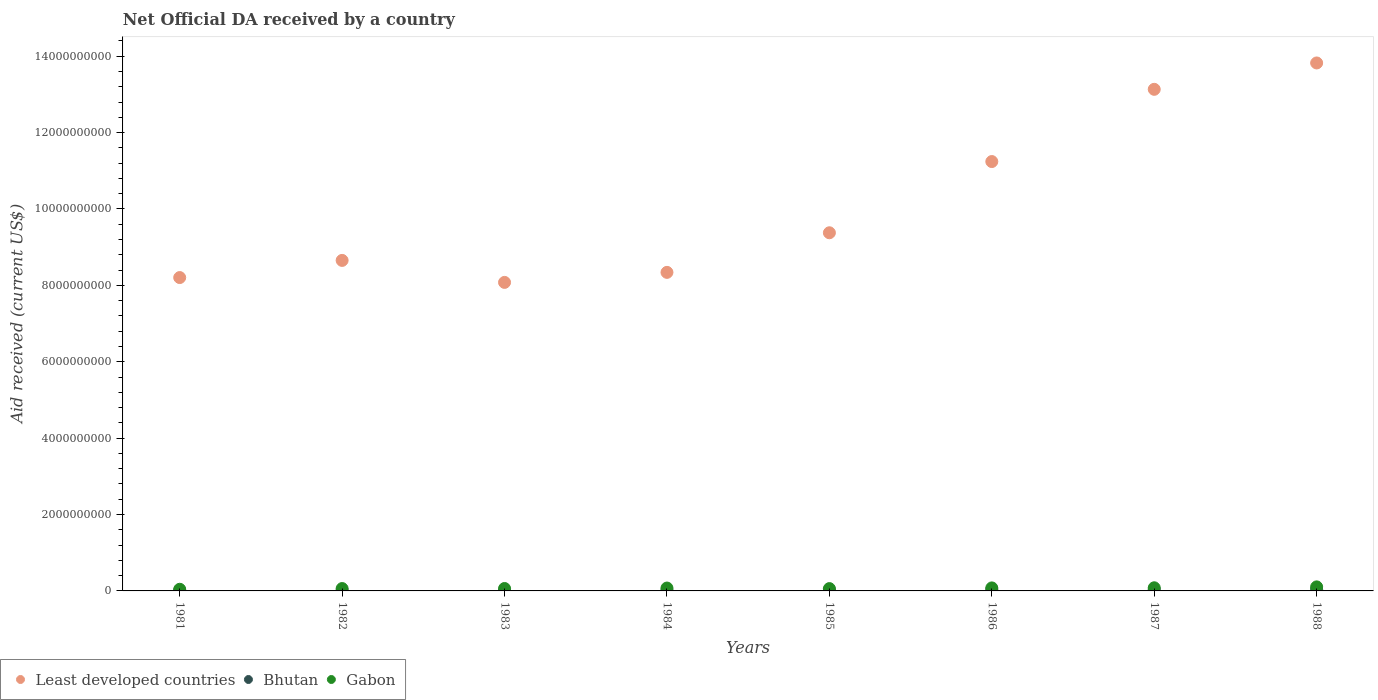Is the number of dotlines equal to the number of legend labels?
Your answer should be very brief. Yes. What is the net official development assistance aid received in Bhutan in 1981?
Your response must be concise. 9.65e+06. Across all years, what is the maximum net official development assistance aid received in Gabon?
Keep it short and to the point. 1.06e+08. Across all years, what is the minimum net official development assistance aid received in Gabon?
Your response must be concise. 4.32e+07. In which year was the net official development assistance aid received in Bhutan maximum?
Your response must be concise. 1988. In which year was the net official development assistance aid received in Gabon minimum?
Offer a very short reply. 1981. What is the total net official development assistance aid received in Least developed countries in the graph?
Provide a succinct answer. 8.08e+1. What is the difference between the net official development assistance aid received in Bhutan in 1985 and that in 1986?
Your answer should be compact. -1.55e+07. What is the difference between the net official development assistance aid received in Gabon in 1984 and the net official development assistance aid received in Bhutan in 1983?
Your response must be concise. 6.24e+07. What is the average net official development assistance aid received in Least developed countries per year?
Offer a very short reply. 1.01e+1. In the year 1981, what is the difference between the net official development assistance aid received in Gabon and net official development assistance aid received in Least developed countries?
Your answer should be very brief. -8.16e+09. In how many years, is the net official development assistance aid received in Gabon greater than 1200000000 US$?
Give a very brief answer. 0. What is the ratio of the net official development assistance aid received in Gabon in 1983 to that in 1986?
Make the answer very short. 0.81. What is the difference between the highest and the lowest net official development assistance aid received in Gabon?
Make the answer very short. 6.26e+07. Is it the case that in every year, the sum of the net official development assistance aid received in Bhutan and net official development assistance aid received in Gabon  is greater than the net official development assistance aid received in Least developed countries?
Your answer should be very brief. No. Is the net official development assistance aid received in Least developed countries strictly less than the net official development assistance aid received in Bhutan over the years?
Ensure brevity in your answer.  No. How many years are there in the graph?
Keep it short and to the point. 8. Are the values on the major ticks of Y-axis written in scientific E-notation?
Provide a short and direct response. No. Does the graph contain grids?
Offer a terse response. No. How many legend labels are there?
Offer a terse response. 3. What is the title of the graph?
Ensure brevity in your answer.  Net Official DA received by a country. Does "Afghanistan" appear as one of the legend labels in the graph?
Your answer should be compact. No. What is the label or title of the Y-axis?
Provide a short and direct response. Aid received (current US$). What is the Aid received (current US$) in Least developed countries in 1981?
Give a very brief answer. 8.20e+09. What is the Aid received (current US$) in Bhutan in 1981?
Your response must be concise. 9.65e+06. What is the Aid received (current US$) of Gabon in 1981?
Your answer should be very brief. 4.32e+07. What is the Aid received (current US$) of Least developed countries in 1982?
Your answer should be very brief. 8.65e+09. What is the Aid received (current US$) of Bhutan in 1982?
Offer a terse response. 1.12e+07. What is the Aid received (current US$) of Gabon in 1982?
Offer a very short reply. 6.18e+07. What is the Aid received (current US$) of Least developed countries in 1983?
Keep it short and to the point. 8.08e+09. What is the Aid received (current US$) in Bhutan in 1983?
Ensure brevity in your answer.  1.29e+07. What is the Aid received (current US$) of Gabon in 1983?
Provide a succinct answer. 6.35e+07. What is the Aid received (current US$) of Least developed countries in 1984?
Provide a short and direct response. 8.34e+09. What is the Aid received (current US$) in Bhutan in 1984?
Offer a very short reply. 1.72e+07. What is the Aid received (current US$) in Gabon in 1984?
Provide a succinct answer. 7.53e+07. What is the Aid received (current US$) of Least developed countries in 1985?
Your answer should be very brief. 9.38e+09. What is the Aid received (current US$) of Bhutan in 1985?
Your response must be concise. 2.34e+07. What is the Aid received (current US$) in Gabon in 1985?
Give a very brief answer. 6.08e+07. What is the Aid received (current US$) in Least developed countries in 1986?
Provide a short and direct response. 1.12e+1. What is the Aid received (current US$) of Bhutan in 1986?
Provide a short and direct response. 3.89e+07. What is the Aid received (current US$) of Gabon in 1986?
Your answer should be compact. 7.86e+07. What is the Aid received (current US$) of Least developed countries in 1987?
Your answer should be compact. 1.31e+1. What is the Aid received (current US$) in Bhutan in 1987?
Make the answer very short. 4.05e+07. What is the Aid received (current US$) of Gabon in 1987?
Make the answer very short. 8.23e+07. What is the Aid received (current US$) of Least developed countries in 1988?
Give a very brief answer. 1.38e+1. What is the Aid received (current US$) of Bhutan in 1988?
Provide a succinct answer. 4.06e+07. What is the Aid received (current US$) in Gabon in 1988?
Your answer should be compact. 1.06e+08. Across all years, what is the maximum Aid received (current US$) in Least developed countries?
Make the answer very short. 1.38e+1. Across all years, what is the maximum Aid received (current US$) in Bhutan?
Provide a short and direct response. 4.06e+07. Across all years, what is the maximum Aid received (current US$) in Gabon?
Offer a very short reply. 1.06e+08. Across all years, what is the minimum Aid received (current US$) of Least developed countries?
Provide a short and direct response. 8.08e+09. Across all years, what is the minimum Aid received (current US$) in Bhutan?
Provide a short and direct response. 9.65e+06. Across all years, what is the minimum Aid received (current US$) in Gabon?
Make the answer very short. 4.32e+07. What is the total Aid received (current US$) in Least developed countries in the graph?
Keep it short and to the point. 8.08e+1. What is the total Aid received (current US$) in Bhutan in the graph?
Provide a succinct answer. 1.94e+08. What is the total Aid received (current US$) in Gabon in the graph?
Your answer should be very brief. 5.71e+08. What is the difference between the Aid received (current US$) in Least developed countries in 1981 and that in 1982?
Your answer should be compact. -4.49e+08. What is the difference between the Aid received (current US$) of Bhutan in 1981 and that in 1982?
Provide a short and direct response. -1.60e+06. What is the difference between the Aid received (current US$) in Gabon in 1981 and that in 1982?
Offer a terse response. -1.87e+07. What is the difference between the Aid received (current US$) in Least developed countries in 1981 and that in 1983?
Keep it short and to the point. 1.27e+08. What is the difference between the Aid received (current US$) of Bhutan in 1981 and that in 1983?
Your response must be concise. -3.27e+06. What is the difference between the Aid received (current US$) of Gabon in 1981 and that in 1983?
Your answer should be compact. -2.03e+07. What is the difference between the Aid received (current US$) of Least developed countries in 1981 and that in 1984?
Provide a short and direct response. -1.36e+08. What is the difference between the Aid received (current US$) of Bhutan in 1981 and that in 1984?
Give a very brief answer. -7.59e+06. What is the difference between the Aid received (current US$) of Gabon in 1981 and that in 1984?
Provide a short and direct response. -3.21e+07. What is the difference between the Aid received (current US$) in Least developed countries in 1981 and that in 1985?
Provide a succinct answer. -1.17e+09. What is the difference between the Aid received (current US$) in Bhutan in 1981 and that in 1985?
Offer a terse response. -1.37e+07. What is the difference between the Aid received (current US$) in Gabon in 1981 and that in 1985?
Provide a succinct answer. -1.76e+07. What is the difference between the Aid received (current US$) of Least developed countries in 1981 and that in 1986?
Ensure brevity in your answer.  -3.04e+09. What is the difference between the Aid received (current US$) in Bhutan in 1981 and that in 1986?
Offer a terse response. -2.93e+07. What is the difference between the Aid received (current US$) in Gabon in 1981 and that in 1986?
Offer a very short reply. -3.55e+07. What is the difference between the Aid received (current US$) of Least developed countries in 1981 and that in 1987?
Make the answer very short. -4.93e+09. What is the difference between the Aid received (current US$) in Bhutan in 1981 and that in 1987?
Provide a succinct answer. -3.08e+07. What is the difference between the Aid received (current US$) of Gabon in 1981 and that in 1987?
Make the answer very short. -3.91e+07. What is the difference between the Aid received (current US$) in Least developed countries in 1981 and that in 1988?
Make the answer very short. -5.62e+09. What is the difference between the Aid received (current US$) of Bhutan in 1981 and that in 1988?
Your answer should be very brief. -3.10e+07. What is the difference between the Aid received (current US$) of Gabon in 1981 and that in 1988?
Give a very brief answer. -6.26e+07. What is the difference between the Aid received (current US$) of Least developed countries in 1982 and that in 1983?
Your response must be concise. 5.76e+08. What is the difference between the Aid received (current US$) of Bhutan in 1982 and that in 1983?
Make the answer very short. -1.67e+06. What is the difference between the Aid received (current US$) in Gabon in 1982 and that in 1983?
Your answer should be compact. -1.61e+06. What is the difference between the Aid received (current US$) of Least developed countries in 1982 and that in 1984?
Make the answer very short. 3.13e+08. What is the difference between the Aid received (current US$) of Bhutan in 1982 and that in 1984?
Offer a terse response. -5.99e+06. What is the difference between the Aid received (current US$) in Gabon in 1982 and that in 1984?
Offer a very short reply. -1.34e+07. What is the difference between the Aid received (current US$) in Least developed countries in 1982 and that in 1985?
Keep it short and to the point. -7.24e+08. What is the difference between the Aid received (current US$) in Bhutan in 1982 and that in 1985?
Provide a succinct answer. -1.21e+07. What is the difference between the Aid received (current US$) of Gabon in 1982 and that in 1985?
Make the answer very short. 1.10e+06. What is the difference between the Aid received (current US$) in Least developed countries in 1982 and that in 1986?
Provide a succinct answer. -2.59e+09. What is the difference between the Aid received (current US$) of Bhutan in 1982 and that in 1986?
Your answer should be compact. -2.77e+07. What is the difference between the Aid received (current US$) of Gabon in 1982 and that in 1986?
Provide a succinct answer. -1.68e+07. What is the difference between the Aid received (current US$) of Least developed countries in 1982 and that in 1987?
Offer a terse response. -4.48e+09. What is the difference between the Aid received (current US$) of Bhutan in 1982 and that in 1987?
Provide a short and direct response. -2.92e+07. What is the difference between the Aid received (current US$) of Gabon in 1982 and that in 1987?
Keep it short and to the point. -2.04e+07. What is the difference between the Aid received (current US$) of Least developed countries in 1982 and that in 1988?
Your response must be concise. -5.17e+09. What is the difference between the Aid received (current US$) in Bhutan in 1982 and that in 1988?
Your answer should be very brief. -2.94e+07. What is the difference between the Aid received (current US$) in Gabon in 1982 and that in 1988?
Offer a very short reply. -4.39e+07. What is the difference between the Aid received (current US$) in Least developed countries in 1983 and that in 1984?
Offer a terse response. -2.62e+08. What is the difference between the Aid received (current US$) of Bhutan in 1983 and that in 1984?
Offer a very short reply. -4.32e+06. What is the difference between the Aid received (current US$) in Gabon in 1983 and that in 1984?
Offer a very short reply. -1.18e+07. What is the difference between the Aid received (current US$) in Least developed countries in 1983 and that in 1985?
Provide a succinct answer. -1.30e+09. What is the difference between the Aid received (current US$) of Bhutan in 1983 and that in 1985?
Keep it short and to the point. -1.05e+07. What is the difference between the Aid received (current US$) in Gabon in 1983 and that in 1985?
Provide a short and direct response. 2.71e+06. What is the difference between the Aid received (current US$) in Least developed countries in 1983 and that in 1986?
Make the answer very short. -3.16e+09. What is the difference between the Aid received (current US$) of Bhutan in 1983 and that in 1986?
Keep it short and to the point. -2.60e+07. What is the difference between the Aid received (current US$) of Gabon in 1983 and that in 1986?
Your answer should be very brief. -1.52e+07. What is the difference between the Aid received (current US$) of Least developed countries in 1983 and that in 1987?
Your answer should be compact. -5.05e+09. What is the difference between the Aid received (current US$) in Bhutan in 1983 and that in 1987?
Ensure brevity in your answer.  -2.75e+07. What is the difference between the Aid received (current US$) of Gabon in 1983 and that in 1987?
Offer a very short reply. -1.88e+07. What is the difference between the Aid received (current US$) in Least developed countries in 1983 and that in 1988?
Offer a very short reply. -5.75e+09. What is the difference between the Aid received (current US$) of Bhutan in 1983 and that in 1988?
Ensure brevity in your answer.  -2.77e+07. What is the difference between the Aid received (current US$) of Gabon in 1983 and that in 1988?
Provide a succinct answer. -4.23e+07. What is the difference between the Aid received (current US$) of Least developed countries in 1984 and that in 1985?
Your response must be concise. -1.04e+09. What is the difference between the Aid received (current US$) in Bhutan in 1984 and that in 1985?
Provide a succinct answer. -6.15e+06. What is the difference between the Aid received (current US$) of Gabon in 1984 and that in 1985?
Your response must be concise. 1.45e+07. What is the difference between the Aid received (current US$) in Least developed countries in 1984 and that in 1986?
Your response must be concise. -2.90e+09. What is the difference between the Aid received (current US$) of Bhutan in 1984 and that in 1986?
Offer a terse response. -2.17e+07. What is the difference between the Aid received (current US$) in Gabon in 1984 and that in 1986?
Your answer should be very brief. -3.37e+06. What is the difference between the Aid received (current US$) in Least developed countries in 1984 and that in 1987?
Ensure brevity in your answer.  -4.79e+09. What is the difference between the Aid received (current US$) in Bhutan in 1984 and that in 1987?
Ensure brevity in your answer.  -2.32e+07. What is the difference between the Aid received (current US$) in Gabon in 1984 and that in 1987?
Make the answer very short. -6.98e+06. What is the difference between the Aid received (current US$) of Least developed countries in 1984 and that in 1988?
Provide a short and direct response. -5.48e+09. What is the difference between the Aid received (current US$) of Bhutan in 1984 and that in 1988?
Your answer should be compact. -2.34e+07. What is the difference between the Aid received (current US$) of Gabon in 1984 and that in 1988?
Your answer should be compact. -3.05e+07. What is the difference between the Aid received (current US$) of Least developed countries in 1985 and that in 1986?
Provide a short and direct response. -1.86e+09. What is the difference between the Aid received (current US$) of Bhutan in 1985 and that in 1986?
Your answer should be very brief. -1.55e+07. What is the difference between the Aid received (current US$) of Gabon in 1985 and that in 1986?
Your answer should be compact. -1.79e+07. What is the difference between the Aid received (current US$) of Least developed countries in 1985 and that in 1987?
Ensure brevity in your answer.  -3.76e+09. What is the difference between the Aid received (current US$) in Bhutan in 1985 and that in 1987?
Provide a short and direct response. -1.71e+07. What is the difference between the Aid received (current US$) of Gabon in 1985 and that in 1987?
Ensure brevity in your answer.  -2.15e+07. What is the difference between the Aid received (current US$) in Least developed countries in 1985 and that in 1988?
Your response must be concise. -4.45e+09. What is the difference between the Aid received (current US$) of Bhutan in 1985 and that in 1988?
Your answer should be very brief. -1.73e+07. What is the difference between the Aid received (current US$) of Gabon in 1985 and that in 1988?
Make the answer very short. -4.50e+07. What is the difference between the Aid received (current US$) of Least developed countries in 1986 and that in 1987?
Your answer should be very brief. -1.89e+09. What is the difference between the Aid received (current US$) in Bhutan in 1986 and that in 1987?
Give a very brief answer. -1.53e+06. What is the difference between the Aid received (current US$) of Gabon in 1986 and that in 1987?
Provide a succinct answer. -3.61e+06. What is the difference between the Aid received (current US$) of Least developed countries in 1986 and that in 1988?
Provide a short and direct response. -2.58e+09. What is the difference between the Aid received (current US$) of Bhutan in 1986 and that in 1988?
Make the answer very short. -1.72e+06. What is the difference between the Aid received (current US$) in Gabon in 1986 and that in 1988?
Your answer should be very brief. -2.71e+07. What is the difference between the Aid received (current US$) of Least developed countries in 1987 and that in 1988?
Provide a short and direct response. -6.90e+08. What is the difference between the Aid received (current US$) of Gabon in 1987 and that in 1988?
Your response must be concise. -2.35e+07. What is the difference between the Aid received (current US$) of Least developed countries in 1981 and the Aid received (current US$) of Bhutan in 1982?
Ensure brevity in your answer.  8.19e+09. What is the difference between the Aid received (current US$) in Least developed countries in 1981 and the Aid received (current US$) in Gabon in 1982?
Make the answer very short. 8.14e+09. What is the difference between the Aid received (current US$) in Bhutan in 1981 and the Aid received (current US$) in Gabon in 1982?
Ensure brevity in your answer.  -5.22e+07. What is the difference between the Aid received (current US$) of Least developed countries in 1981 and the Aid received (current US$) of Bhutan in 1983?
Your answer should be very brief. 8.19e+09. What is the difference between the Aid received (current US$) in Least developed countries in 1981 and the Aid received (current US$) in Gabon in 1983?
Provide a succinct answer. 8.14e+09. What is the difference between the Aid received (current US$) of Bhutan in 1981 and the Aid received (current US$) of Gabon in 1983?
Provide a succinct answer. -5.38e+07. What is the difference between the Aid received (current US$) in Least developed countries in 1981 and the Aid received (current US$) in Bhutan in 1984?
Your response must be concise. 8.19e+09. What is the difference between the Aid received (current US$) in Least developed countries in 1981 and the Aid received (current US$) in Gabon in 1984?
Make the answer very short. 8.13e+09. What is the difference between the Aid received (current US$) in Bhutan in 1981 and the Aid received (current US$) in Gabon in 1984?
Provide a short and direct response. -6.56e+07. What is the difference between the Aid received (current US$) in Least developed countries in 1981 and the Aid received (current US$) in Bhutan in 1985?
Your response must be concise. 8.18e+09. What is the difference between the Aid received (current US$) in Least developed countries in 1981 and the Aid received (current US$) in Gabon in 1985?
Make the answer very short. 8.14e+09. What is the difference between the Aid received (current US$) in Bhutan in 1981 and the Aid received (current US$) in Gabon in 1985?
Your answer should be very brief. -5.11e+07. What is the difference between the Aid received (current US$) of Least developed countries in 1981 and the Aid received (current US$) of Bhutan in 1986?
Make the answer very short. 8.17e+09. What is the difference between the Aid received (current US$) in Least developed countries in 1981 and the Aid received (current US$) in Gabon in 1986?
Keep it short and to the point. 8.13e+09. What is the difference between the Aid received (current US$) in Bhutan in 1981 and the Aid received (current US$) in Gabon in 1986?
Your response must be concise. -6.90e+07. What is the difference between the Aid received (current US$) in Least developed countries in 1981 and the Aid received (current US$) in Bhutan in 1987?
Ensure brevity in your answer.  8.16e+09. What is the difference between the Aid received (current US$) in Least developed countries in 1981 and the Aid received (current US$) in Gabon in 1987?
Your answer should be compact. 8.12e+09. What is the difference between the Aid received (current US$) of Bhutan in 1981 and the Aid received (current US$) of Gabon in 1987?
Your answer should be very brief. -7.26e+07. What is the difference between the Aid received (current US$) of Least developed countries in 1981 and the Aid received (current US$) of Bhutan in 1988?
Your answer should be very brief. 8.16e+09. What is the difference between the Aid received (current US$) in Least developed countries in 1981 and the Aid received (current US$) in Gabon in 1988?
Keep it short and to the point. 8.10e+09. What is the difference between the Aid received (current US$) in Bhutan in 1981 and the Aid received (current US$) in Gabon in 1988?
Ensure brevity in your answer.  -9.61e+07. What is the difference between the Aid received (current US$) of Least developed countries in 1982 and the Aid received (current US$) of Bhutan in 1983?
Offer a very short reply. 8.64e+09. What is the difference between the Aid received (current US$) of Least developed countries in 1982 and the Aid received (current US$) of Gabon in 1983?
Make the answer very short. 8.59e+09. What is the difference between the Aid received (current US$) of Bhutan in 1982 and the Aid received (current US$) of Gabon in 1983?
Give a very brief answer. -5.22e+07. What is the difference between the Aid received (current US$) in Least developed countries in 1982 and the Aid received (current US$) in Bhutan in 1984?
Your response must be concise. 8.64e+09. What is the difference between the Aid received (current US$) in Least developed countries in 1982 and the Aid received (current US$) in Gabon in 1984?
Make the answer very short. 8.58e+09. What is the difference between the Aid received (current US$) in Bhutan in 1982 and the Aid received (current US$) in Gabon in 1984?
Give a very brief answer. -6.40e+07. What is the difference between the Aid received (current US$) in Least developed countries in 1982 and the Aid received (current US$) in Bhutan in 1985?
Offer a very short reply. 8.63e+09. What is the difference between the Aid received (current US$) in Least developed countries in 1982 and the Aid received (current US$) in Gabon in 1985?
Offer a very short reply. 8.59e+09. What is the difference between the Aid received (current US$) in Bhutan in 1982 and the Aid received (current US$) in Gabon in 1985?
Offer a very short reply. -4.95e+07. What is the difference between the Aid received (current US$) in Least developed countries in 1982 and the Aid received (current US$) in Bhutan in 1986?
Your answer should be very brief. 8.61e+09. What is the difference between the Aid received (current US$) of Least developed countries in 1982 and the Aid received (current US$) of Gabon in 1986?
Offer a very short reply. 8.57e+09. What is the difference between the Aid received (current US$) of Bhutan in 1982 and the Aid received (current US$) of Gabon in 1986?
Keep it short and to the point. -6.74e+07. What is the difference between the Aid received (current US$) of Least developed countries in 1982 and the Aid received (current US$) of Bhutan in 1987?
Offer a very short reply. 8.61e+09. What is the difference between the Aid received (current US$) of Least developed countries in 1982 and the Aid received (current US$) of Gabon in 1987?
Give a very brief answer. 8.57e+09. What is the difference between the Aid received (current US$) of Bhutan in 1982 and the Aid received (current US$) of Gabon in 1987?
Make the answer very short. -7.10e+07. What is the difference between the Aid received (current US$) in Least developed countries in 1982 and the Aid received (current US$) in Bhutan in 1988?
Provide a short and direct response. 8.61e+09. What is the difference between the Aid received (current US$) in Least developed countries in 1982 and the Aid received (current US$) in Gabon in 1988?
Give a very brief answer. 8.55e+09. What is the difference between the Aid received (current US$) of Bhutan in 1982 and the Aid received (current US$) of Gabon in 1988?
Give a very brief answer. -9.45e+07. What is the difference between the Aid received (current US$) of Least developed countries in 1983 and the Aid received (current US$) of Bhutan in 1984?
Provide a short and direct response. 8.06e+09. What is the difference between the Aid received (current US$) in Least developed countries in 1983 and the Aid received (current US$) in Gabon in 1984?
Your response must be concise. 8.00e+09. What is the difference between the Aid received (current US$) in Bhutan in 1983 and the Aid received (current US$) in Gabon in 1984?
Make the answer very short. -6.24e+07. What is the difference between the Aid received (current US$) of Least developed countries in 1983 and the Aid received (current US$) of Bhutan in 1985?
Make the answer very short. 8.05e+09. What is the difference between the Aid received (current US$) in Least developed countries in 1983 and the Aid received (current US$) in Gabon in 1985?
Ensure brevity in your answer.  8.02e+09. What is the difference between the Aid received (current US$) in Bhutan in 1983 and the Aid received (current US$) in Gabon in 1985?
Your answer should be very brief. -4.78e+07. What is the difference between the Aid received (current US$) in Least developed countries in 1983 and the Aid received (current US$) in Bhutan in 1986?
Ensure brevity in your answer.  8.04e+09. What is the difference between the Aid received (current US$) in Least developed countries in 1983 and the Aid received (current US$) in Gabon in 1986?
Make the answer very short. 8.00e+09. What is the difference between the Aid received (current US$) of Bhutan in 1983 and the Aid received (current US$) of Gabon in 1986?
Make the answer very short. -6.57e+07. What is the difference between the Aid received (current US$) in Least developed countries in 1983 and the Aid received (current US$) in Bhutan in 1987?
Your answer should be compact. 8.04e+09. What is the difference between the Aid received (current US$) of Least developed countries in 1983 and the Aid received (current US$) of Gabon in 1987?
Your answer should be very brief. 8.00e+09. What is the difference between the Aid received (current US$) in Bhutan in 1983 and the Aid received (current US$) in Gabon in 1987?
Offer a terse response. -6.93e+07. What is the difference between the Aid received (current US$) in Least developed countries in 1983 and the Aid received (current US$) in Bhutan in 1988?
Ensure brevity in your answer.  8.04e+09. What is the difference between the Aid received (current US$) in Least developed countries in 1983 and the Aid received (current US$) in Gabon in 1988?
Offer a terse response. 7.97e+09. What is the difference between the Aid received (current US$) of Bhutan in 1983 and the Aid received (current US$) of Gabon in 1988?
Ensure brevity in your answer.  -9.28e+07. What is the difference between the Aid received (current US$) of Least developed countries in 1984 and the Aid received (current US$) of Bhutan in 1985?
Make the answer very short. 8.32e+09. What is the difference between the Aid received (current US$) of Least developed countries in 1984 and the Aid received (current US$) of Gabon in 1985?
Your answer should be compact. 8.28e+09. What is the difference between the Aid received (current US$) in Bhutan in 1984 and the Aid received (current US$) in Gabon in 1985?
Give a very brief answer. -4.35e+07. What is the difference between the Aid received (current US$) of Least developed countries in 1984 and the Aid received (current US$) of Bhutan in 1986?
Provide a succinct answer. 8.30e+09. What is the difference between the Aid received (current US$) of Least developed countries in 1984 and the Aid received (current US$) of Gabon in 1986?
Your answer should be compact. 8.26e+09. What is the difference between the Aid received (current US$) of Bhutan in 1984 and the Aid received (current US$) of Gabon in 1986?
Offer a terse response. -6.14e+07. What is the difference between the Aid received (current US$) of Least developed countries in 1984 and the Aid received (current US$) of Bhutan in 1987?
Provide a succinct answer. 8.30e+09. What is the difference between the Aid received (current US$) in Least developed countries in 1984 and the Aid received (current US$) in Gabon in 1987?
Provide a succinct answer. 8.26e+09. What is the difference between the Aid received (current US$) of Bhutan in 1984 and the Aid received (current US$) of Gabon in 1987?
Make the answer very short. -6.50e+07. What is the difference between the Aid received (current US$) in Least developed countries in 1984 and the Aid received (current US$) in Bhutan in 1988?
Your response must be concise. 8.30e+09. What is the difference between the Aid received (current US$) of Least developed countries in 1984 and the Aid received (current US$) of Gabon in 1988?
Provide a succinct answer. 8.23e+09. What is the difference between the Aid received (current US$) in Bhutan in 1984 and the Aid received (current US$) in Gabon in 1988?
Your answer should be very brief. -8.85e+07. What is the difference between the Aid received (current US$) of Least developed countries in 1985 and the Aid received (current US$) of Bhutan in 1986?
Make the answer very short. 9.34e+09. What is the difference between the Aid received (current US$) of Least developed countries in 1985 and the Aid received (current US$) of Gabon in 1986?
Your response must be concise. 9.30e+09. What is the difference between the Aid received (current US$) of Bhutan in 1985 and the Aid received (current US$) of Gabon in 1986?
Provide a short and direct response. -5.53e+07. What is the difference between the Aid received (current US$) of Least developed countries in 1985 and the Aid received (current US$) of Bhutan in 1987?
Offer a very short reply. 9.34e+09. What is the difference between the Aid received (current US$) of Least developed countries in 1985 and the Aid received (current US$) of Gabon in 1987?
Provide a short and direct response. 9.29e+09. What is the difference between the Aid received (current US$) of Bhutan in 1985 and the Aid received (current US$) of Gabon in 1987?
Give a very brief answer. -5.89e+07. What is the difference between the Aid received (current US$) in Least developed countries in 1985 and the Aid received (current US$) in Bhutan in 1988?
Ensure brevity in your answer.  9.34e+09. What is the difference between the Aid received (current US$) in Least developed countries in 1985 and the Aid received (current US$) in Gabon in 1988?
Offer a very short reply. 9.27e+09. What is the difference between the Aid received (current US$) in Bhutan in 1985 and the Aid received (current US$) in Gabon in 1988?
Ensure brevity in your answer.  -8.24e+07. What is the difference between the Aid received (current US$) in Least developed countries in 1986 and the Aid received (current US$) in Bhutan in 1987?
Keep it short and to the point. 1.12e+1. What is the difference between the Aid received (current US$) in Least developed countries in 1986 and the Aid received (current US$) in Gabon in 1987?
Your answer should be compact. 1.12e+1. What is the difference between the Aid received (current US$) of Bhutan in 1986 and the Aid received (current US$) of Gabon in 1987?
Offer a very short reply. -4.33e+07. What is the difference between the Aid received (current US$) in Least developed countries in 1986 and the Aid received (current US$) in Bhutan in 1988?
Provide a short and direct response. 1.12e+1. What is the difference between the Aid received (current US$) of Least developed countries in 1986 and the Aid received (current US$) of Gabon in 1988?
Provide a short and direct response. 1.11e+1. What is the difference between the Aid received (current US$) in Bhutan in 1986 and the Aid received (current US$) in Gabon in 1988?
Provide a short and direct response. -6.68e+07. What is the difference between the Aid received (current US$) in Least developed countries in 1987 and the Aid received (current US$) in Bhutan in 1988?
Make the answer very short. 1.31e+1. What is the difference between the Aid received (current US$) of Least developed countries in 1987 and the Aid received (current US$) of Gabon in 1988?
Ensure brevity in your answer.  1.30e+1. What is the difference between the Aid received (current US$) in Bhutan in 1987 and the Aid received (current US$) in Gabon in 1988?
Ensure brevity in your answer.  -6.53e+07. What is the average Aid received (current US$) of Least developed countries per year?
Ensure brevity in your answer.  1.01e+1. What is the average Aid received (current US$) in Bhutan per year?
Keep it short and to the point. 2.43e+07. What is the average Aid received (current US$) in Gabon per year?
Your answer should be compact. 7.14e+07. In the year 1981, what is the difference between the Aid received (current US$) of Least developed countries and Aid received (current US$) of Bhutan?
Your response must be concise. 8.19e+09. In the year 1981, what is the difference between the Aid received (current US$) of Least developed countries and Aid received (current US$) of Gabon?
Your answer should be compact. 8.16e+09. In the year 1981, what is the difference between the Aid received (current US$) of Bhutan and Aid received (current US$) of Gabon?
Keep it short and to the point. -3.35e+07. In the year 1982, what is the difference between the Aid received (current US$) of Least developed countries and Aid received (current US$) of Bhutan?
Make the answer very short. 8.64e+09. In the year 1982, what is the difference between the Aid received (current US$) in Least developed countries and Aid received (current US$) in Gabon?
Provide a succinct answer. 8.59e+09. In the year 1982, what is the difference between the Aid received (current US$) of Bhutan and Aid received (current US$) of Gabon?
Your answer should be very brief. -5.06e+07. In the year 1983, what is the difference between the Aid received (current US$) in Least developed countries and Aid received (current US$) in Bhutan?
Provide a succinct answer. 8.06e+09. In the year 1983, what is the difference between the Aid received (current US$) in Least developed countries and Aid received (current US$) in Gabon?
Offer a terse response. 8.01e+09. In the year 1983, what is the difference between the Aid received (current US$) in Bhutan and Aid received (current US$) in Gabon?
Provide a succinct answer. -5.05e+07. In the year 1984, what is the difference between the Aid received (current US$) of Least developed countries and Aid received (current US$) of Bhutan?
Provide a short and direct response. 8.32e+09. In the year 1984, what is the difference between the Aid received (current US$) of Least developed countries and Aid received (current US$) of Gabon?
Provide a short and direct response. 8.26e+09. In the year 1984, what is the difference between the Aid received (current US$) of Bhutan and Aid received (current US$) of Gabon?
Make the answer very short. -5.80e+07. In the year 1985, what is the difference between the Aid received (current US$) of Least developed countries and Aid received (current US$) of Bhutan?
Offer a terse response. 9.35e+09. In the year 1985, what is the difference between the Aid received (current US$) in Least developed countries and Aid received (current US$) in Gabon?
Your response must be concise. 9.32e+09. In the year 1985, what is the difference between the Aid received (current US$) in Bhutan and Aid received (current US$) in Gabon?
Give a very brief answer. -3.74e+07. In the year 1986, what is the difference between the Aid received (current US$) in Least developed countries and Aid received (current US$) in Bhutan?
Your answer should be compact. 1.12e+1. In the year 1986, what is the difference between the Aid received (current US$) in Least developed countries and Aid received (current US$) in Gabon?
Provide a succinct answer. 1.12e+1. In the year 1986, what is the difference between the Aid received (current US$) in Bhutan and Aid received (current US$) in Gabon?
Provide a short and direct response. -3.97e+07. In the year 1987, what is the difference between the Aid received (current US$) of Least developed countries and Aid received (current US$) of Bhutan?
Your response must be concise. 1.31e+1. In the year 1987, what is the difference between the Aid received (current US$) in Least developed countries and Aid received (current US$) in Gabon?
Ensure brevity in your answer.  1.31e+1. In the year 1987, what is the difference between the Aid received (current US$) in Bhutan and Aid received (current US$) in Gabon?
Offer a terse response. -4.18e+07. In the year 1988, what is the difference between the Aid received (current US$) in Least developed countries and Aid received (current US$) in Bhutan?
Offer a terse response. 1.38e+1. In the year 1988, what is the difference between the Aid received (current US$) in Least developed countries and Aid received (current US$) in Gabon?
Ensure brevity in your answer.  1.37e+1. In the year 1988, what is the difference between the Aid received (current US$) of Bhutan and Aid received (current US$) of Gabon?
Provide a short and direct response. -6.51e+07. What is the ratio of the Aid received (current US$) of Least developed countries in 1981 to that in 1982?
Ensure brevity in your answer.  0.95. What is the ratio of the Aid received (current US$) in Bhutan in 1981 to that in 1982?
Your answer should be very brief. 0.86. What is the ratio of the Aid received (current US$) in Gabon in 1981 to that in 1982?
Ensure brevity in your answer.  0.7. What is the ratio of the Aid received (current US$) in Least developed countries in 1981 to that in 1983?
Your answer should be compact. 1.02. What is the ratio of the Aid received (current US$) in Bhutan in 1981 to that in 1983?
Provide a short and direct response. 0.75. What is the ratio of the Aid received (current US$) of Gabon in 1981 to that in 1983?
Provide a short and direct response. 0.68. What is the ratio of the Aid received (current US$) of Least developed countries in 1981 to that in 1984?
Your response must be concise. 0.98. What is the ratio of the Aid received (current US$) of Bhutan in 1981 to that in 1984?
Give a very brief answer. 0.56. What is the ratio of the Aid received (current US$) of Gabon in 1981 to that in 1984?
Offer a very short reply. 0.57. What is the ratio of the Aid received (current US$) of Least developed countries in 1981 to that in 1985?
Ensure brevity in your answer.  0.87. What is the ratio of the Aid received (current US$) of Bhutan in 1981 to that in 1985?
Offer a terse response. 0.41. What is the ratio of the Aid received (current US$) in Gabon in 1981 to that in 1985?
Give a very brief answer. 0.71. What is the ratio of the Aid received (current US$) in Least developed countries in 1981 to that in 1986?
Give a very brief answer. 0.73. What is the ratio of the Aid received (current US$) of Bhutan in 1981 to that in 1986?
Give a very brief answer. 0.25. What is the ratio of the Aid received (current US$) of Gabon in 1981 to that in 1986?
Provide a short and direct response. 0.55. What is the ratio of the Aid received (current US$) of Least developed countries in 1981 to that in 1987?
Make the answer very short. 0.62. What is the ratio of the Aid received (current US$) in Bhutan in 1981 to that in 1987?
Offer a very short reply. 0.24. What is the ratio of the Aid received (current US$) of Gabon in 1981 to that in 1987?
Give a very brief answer. 0.52. What is the ratio of the Aid received (current US$) of Least developed countries in 1981 to that in 1988?
Give a very brief answer. 0.59. What is the ratio of the Aid received (current US$) of Bhutan in 1981 to that in 1988?
Your answer should be compact. 0.24. What is the ratio of the Aid received (current US$) of Gabon in 1981 to that in 1988?
Provide a short and direct response. 0.41. What is the ratio of the Aid received (current US$) of Least developed countries in 1982 to that in 1983?
Offer a very short reply. 1.07. What is the ratio of the Aid received (current US$) in Bhutan in 1982 to that in 1983?
Your response must be concise. 0.87. What is the ratio of the Aid received (current US$) in Gabon in 1982 to that in 1983?
Provide a short and direct response. 0.97. What is the ratio of the Aid received (current US$) in Least developed countries in 1982 to that in 1984?
Keep it short and to the point. 1.04. What is the ratio of the Aid received (current US$) of Bhutan in 1982 to that in 1984?
Provide a succinct answer. 0.65. What is the ratio of the Aid received (current US$) in Gabon in 1982 to that in 1984?
Ensure brevity in your answer.  0.82. What is the ratio of the Aid received (current US$) in Least developed countries in 1982 to that in 1985?
Give a very brief answer. 0.92. What is the ratio of the Aid received (current US$) of Bhutan in 1982 to that in 1985?
Your answer should be compact. 0.48. What is the ratio of the Aid received (current US$) in Gabon in 1982 to that in 1985?
Offer a terse response. 1.02. What is the ratio of the Aid received (current US$) of Least developed countries in 1982 to that in 1986?
Keep it short and to the point. 0.77. What is the ratio of the Aid received (current US$) of Bhutan in 1982 to that in 1986?
Your response must be concise. 0.29. What is the ratio of the Aid received (current US$) in Gabon in 1982 to that in 1986?
Provide a short and direct response. 0.79. What is the ratio of the Aid received (current US$) in Least developed countries in 1982 to that in 1987?
Offer a very short reply. 0.66. What is the ratio of the Aid received (current US$) of Bhutan in 1982 to that in 1987?
Offer a terse response. 0.28. What is the ratio of the Aid received (current US$) in Gabon in 1982 to that in 1987?
Keep it short and to the point. 0.75. What is the ratio of the Aid received (current US$) of Least developed countries in 1982 to that in 1988?
Offer a very short reply. 0.63. What is the ratio of the Aid received (current US$) in Bhutan in 1982 to that in 1988?
Offer a very short reply. 0.28. What is the ratio of the Aid received (current US$) in Gabon in 1982 to that in 1988?
Your response must be concise. 0.58. What is the ratio of the Aid received (current US$) in Least developed countries in 1983 to that in 1984?
Provide a short and direct response. 0.97. What is the ratio of the Aid received (current US$) of Bhutan in 1983 to that in 1984?
Offer a terse response. 0.75. What is the ratio of the Aid received (current US$) in Gabon in 1983 to that in 1984?
Provide a short and direct response. 0.84. What is the ratio of the Aid received (current US$) in Least developed countries in 1983 to that in 1985?
Your answer should be very brief. 0.86. What is the ratio of the Aid received (current US$) of Bhutan in 1983 to that in 1985?
Give a very brief answer. 0.55. What is the ratio of the Aid received (current US$) of Gabon in 1983 to that in 1985?
Your answer should be compact. 1.04. What is the ratio of the Aid received (current US$) in Least developed countries in 1983 to that in 1986?
Give a very brief answer. 0.72. What is the ratio of the Aid received (current US$) in Bhutan in 1983 to that in 1986?
Provide a short and direct response. 0.33. What is the ratio of the Aid received (current US$) in Gabon in 1983 to that in 1986?
Your answer should be very brief. 0.81. What is the ratio of the Aid received (current US$) of Least developed countries in 1983 to that in 1987?
Your answer should be very brief. 0.62. What is the ratio of the Aid received (current US$) in Bhutan in 1983 to that in 1987?
Keep it short and to the point. 0.32. What is the ratio of the Aid received (current US$) of Gabon in 1983 to that in 1987?
Provide a succinct answer. 0.77. What is the ratio of the Aid received (current US$) of Least developed countries in 1983 to that in 1988?
Provide a succinct answer. 0.58. What is the ratio of the Aid received (current US$) of Bhutan in 1983 to that in 1988?
Your response must be concise. 0.32. What is the ratio of the Aid received (current US$) of Gabon in 1983 to that in 1988?
Your response must be concise. 0.6. What is the ratio of the Aid received (current US$) in Least developed countries in 1984 to that in 1985?
Your response must be concise. 0.89. What is the ratio of the Aid received (current US$) in Bhutan in 1984 to that in 1985?
Your answer should be very brief. 0.74. What is the ratio of the Aid received (current US$) of Gabon in 1984 to that in 1985?
Offer a very short reply. 1.24. What is the ratio of the Aid received (current US$) in Least developed countries in 1984 to that in 1986?
Offer a terse response. 0.74. What is the ratio of the Aid received (current US$) of Bhutan in 1984 to that in 1986?
Keep it short and to the point. 0.44. What is the ratio of the Aid received (current US$) of Gabon in 1984 to that in 1986?
Your answer should be compact. 0.96. What is the ratio of the Aid received (current US$) in Least developed countries in 1984 to that in 1987?
Ensure brevity in your answer.  0.64. What is the ratio of the Aid received (current US$) in Bhutan in 1984 to that in 1987?
Keep it short and to the point. 0.43. What is the ratio of the Aid received (current US$) of Gabon in 1984 to that in 1987?
Keep it short and to the point. 0.92. What is the ratio of the Aid received (current US$) of Least developed countries in 1984 to that in 1988?
Offer a very short reply. 0.6. What is the ratio of the Aid received (current US$) of Bhutan in 1984 to that in 1988?
Your answer should be compact. 0.42. What is the ratio of the Aid received (current US$) in Gabon in 1984 to that in 1988?
Keep it short and to the point. 0.71. What is the ratio of the Aid received (current US$) of Least developed countries in 1985 to that in 1986?
Give a very brief answer. 0.83. What is the ratio of the Aid received (current US$) in Bhutan in 1985 to that in 1986?
Ensure brevity in your answer.  0.6. What is the ratio of the Aid received (current US$) in Gabon in 1985 to that in 1986?
Make the answer very short. 0.77. What is the ratio of the Aid received (current US$) in Least developed countries in 1985 to that in 1987?
Your response must be concise. 0.71. What is the ratio of the Aid received (current US$) in Bhutan in 1985 to that in 1987?
Your response must be concise. 0.58. What is the ratio of the Aid received (current US$) in Gabon in 1985 to that in 1987?
Provide a succinct answer. 0.74. What is the ratio of the Aid received (current US$) in Least developed countries in 1985 to that in 1988?
Your answer should be compact. 0.68. What is the ratio of the Aid received (current US$) of Bhutan in 1985 to that in 1988?
Ensure brevity in your answer.  0.58. What is the ratio of the Aid received (current US$) of Gabon in 1985 to that in 1988?
Provide a succinct answer. 0.57. What is the ratio of the Aid received (current US$) in Least developed countries in 1986 to that in 1987?
Give a very brief answer. 0.86. What is the ratio of the Aid received (current US$) of Bhutan in 1986 to that in 1987?
Provide a short and direct response. 0.96. What is the ratio of the Aid received (current US$) in Gabon in 1986 to that in 1987?
Offer a very short reply. 0.96. What is the ratio of the Aid received (current US$) in Least developed countries in 1986 to that in 1988?
Ensure brevity in your answer.  0.81. What is the ratio of the Aid received (current US$) in Bhutan in 1986 to that in 1988?
Offer a terse response. 0.96. What is the ratio of the Aid received (current US$) in Gabon in 1986 to that in 1988?
Provide a short and direct response. 0.74. What is the ratio of the Aid received (current US$) of Least developed countries in 1987 to that in 1988?
Your answer should be compact. 0.95. What is the ratio of the Aid received (current US$) of Gabon in 1987 to that in 1988?
Offer a very short reply. 0.78. What is the difference between the highest and the second highest Aid received (current US$) in Least developed countries?
Your answer should be compact. 6.90e+08. What is the difference between the highest and the second highest Aid received (current US$) of Bhutan?
Give a very brief answer. 1.90e+05. What is the difference between the highest and the second highest Aid received (current US$) of Gabon?
Provide a succinct answer. 2.35e+07. What is the difference between the highest and the lowest Aid received (current US$) of Least developed countries?
Offer a terse response. 5.75e+09. What is the difference between the highest and the lowest Aid received (current US$) in Bhutan?
Keep it short and to the point. 3.10e+07. What is the difference between the highest and the lowest Aid received (current US$) of Gabon?
Make the answer very short. 6.26e+07. 